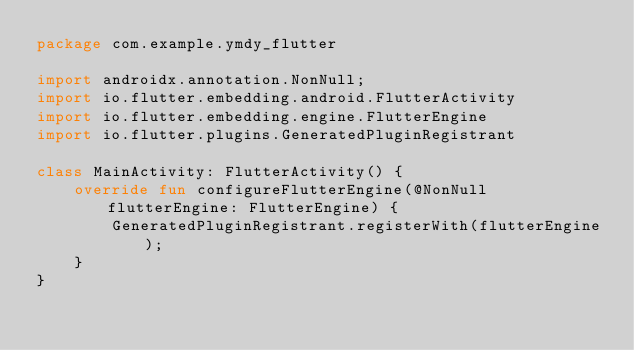<code> <loc_0><loc_0><loc_500><loc_500><_Kotlin_>package com.example.ymdy_flutter

import androidx.annotation.NonNull;
import io.flutter.embedding.android.FlutterActivity
import io.flutter.embedding.engine.FlutterEngine
import io.flutter.plugins.GeneratedPluginRegistrant

class MainActivity: FlutterActivity() {
    override fun configureFlutterEngine(@NonNull flutterEngine: FlutterEngine) {
        GeneratedPluginRegistrant.registerWith(flutterEngine);
    }
}
</code> 